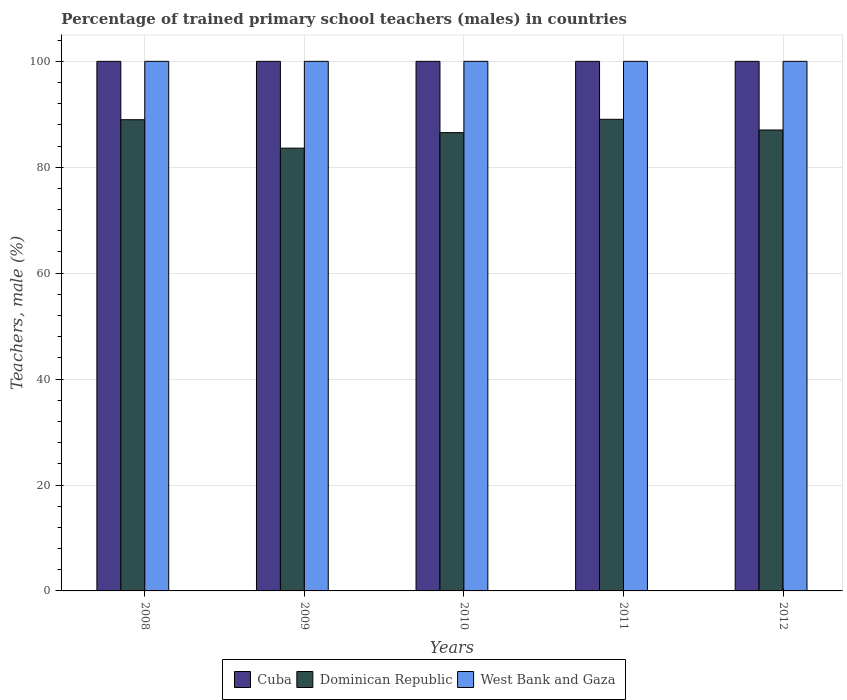Are the number of bars per tick equal to the number of legend labels?
Give a very brief answer. Yes. Are the number of bars on each tick of the X-axis equal?
Offer a terse response. Yes. In how many cases, is the number of bars for a given year not equal to the number of legend labels?
Make the answer very short. 0. What is the percentage of trained primary school teachers (males) in Dominican Republic in 2011?
Make the answer very short. 89.06. Across all years, what is the maximum percentage of trained primary school teachers (males) in Dominican Republic?
Your response must be concise. 89.06. Across all years, what is the minimum percentage of trained primary school teachers (males) in Dominican Republic?
Make the answer very short. 83.61. In which year was the percentage of trained primary school teachers (males) in Dominican Republic maximum?
Offer a terse response. 2011. In which year was the percentage of trained primary school teachers (males) in Dominican Republic minimum?
Offer a very short reply. 2009. What is the total percentage of trained primary school teachers (males) in Dominican Republic in the graph?
Make the answer very short. 435.22. What is the difference between the percentage of trained primary school teachers (males) in Cuba in 2009 and that in 2012?
Provide a short and direct response. 0. What is the difference between the percentage of trained primary school teachers (males) in Cuba in 2011 and the percentage of trained primary school teachers (males) in West Bank and Gaza in 2012?
Provide a succinct answer. 0. In how many years, is the percentage of trained primary school teachers (males) in Dominican Republic greater than 72 %?
Your answer should be compact. 5. What is the difference between the highest and the lowest percentage of trained primary school teachers (males) in West Bank and Gaza?
Make the answer very short. 0. Is the sum of the percentage of trained primary school teachers (males) in Dominican Republic in 2011 and 2012 greater than the maximum percentage of trained primary school teachers (males) in Cuba across all years?
Offer a terse response. Yes. What does the 1st bar from the left in 2010 represents?
Offer a terse response. Cuba. What does the 1st bar from the right in 2010 represents?
Give a very brief answer. West Bank and Gaza. What is the difference between two consecutive major ticks on the Y-axis?
Your response must be concise. 20. Are the values on the major ticks of Y-axis written in scientific E-notation?
Give a very brief answer. No. Does the graph contain grids?
Offer a very short reply. Yes. How many legend labels are there?
Keep it short and to the point. 3. What is the title of the graph?
Provide a succinct answer. Percentage of trained primary school teachers (males) in countries. Does "European Union" appear as one of the legend labels in the graph?
Your answer should be very brief. No. What is the label or title of the X-axis?
Your answer should be very brief. Years. What is the label or title of the Y-axis?
Ensure brevity in your answer.  Teachers, male (%). What is the Teachers, male (%) of Dominican Republic in 2008?
Ensure brevity in your answer.  88.98. What is the Teachers, male (%) of West Bank and Gaza in 2008?
Give a very brief answer. 100. What is the Teachers, male (%) in Cuba in 2009?
Offer a terse response. 100. What is the Teachers, male (%) in Dominican Republic in 2009?
Your answer should be compact. 83.61. What is the Teachers, male (%) of West Bank and Gaza in 2009?
Keep it short and to the point. 100. What is the Teachers, male (%) in Cuba in 2010?
Make the answer very short. 100. What is the Teachers, male (%) of Dominican Republic in 2010?
Keep it short and to the point. 86.54. What is the Teachers, male (%) in Cuba in 2011?
Your answer should be very brief. 100. What is the Teachers, male (%) in Dominican Republic in 2011?
Give a very brief answer. 89.06. What is the Teachers, male (%) of West Bank and Gaza in 2011?
Offer a terse response. 100. What is the Teachers, male (%) of Cuba in 2012?
Keep it short and to the point. 100. What is the Teachers, male (%) of Dominican Republic in 2012?
Provide a short and direct response. 87.04. Across all years, what is the maximum Teachers, male (%) of Dominican Republic?
Offer a very short reply. 89.06. Across all years, what is the minimum Teachers, male (%) of Cuba?
Make the answer very short. 100. Across all years, what is the minimum Teachers, male (%) in Dominican Republic?
Give a very brief answer. 83.61. Across all years, what is the minimum Teachers, male (%) in West Bank and Gaza?
Provide a short and direct response. 100. What is the total Teachers, male (%) in Cuba in the graph?
Provide a short and direct response. 500. What is the total Teachers, male (%) in Dominican Republic in the graph?
Your response must be concise. 435.22. What is the total Teachers, male (%) of West Bank and Gaza in the graph?
Offer a very short reply. 500. What is the difference between the Teachers, male (%) of Cuba in 2008 and that in 2009?
Your response must be concise. 0. What is the difference between the Teachers, male (%) of Dominican Republic in 2008 and that in 2009?
Give a very brief answer. 5.37. What is the difference between the Teachers, male (%) of West Bank and Gaza in 2008 and that in 2009?
Ensure brevity in your answer.  0. What is the difference between the Teachers, male (%) in Cuba in 2008 and that in 2010?
Keep it short and to the point. 0. What is the difference between the Teachers, male (%) of Dominican Republic in 2008 and that in 2010?
Offer a very short reply. 2.44. What is the difference between the Teachers, male (%) of Cuba in 2008 and that in 2011?
Your answer should be very brief. 0. What is the difference between the Teachers, male (%) in Dominican Republic in 2008 and that in 2011?
Your answer should be compact. -0.08. What is the difference between the Teachers, male (%) of West Bank and Gaza in 2008 and that in 2011?
Give a very brief answer. 0. What is the difference between the Teachers, male (%) of Cuba in 2008 and that in 2012?
Keep it short and to the point. 0. What is the difference between the Teachers, male (%) in Dominican Republic in 2008 and that in 2012?
Your answer should be compact. 1.94. What is the difference between the Teachers, male (%) in West Bank and Gaza in 2008 and that in 2012?
Ensure brevity in your answer.  0. What is the difference between the Teachers, male (%) in Cuba in 2009 and that in 2010?
Offer a very short reply. 0. What is the difference between the Teachers, male (%) of Dominican Republic in 2009 and that in 2010?
Provide a succinct answer. -2.93. What is the difference between the Teachers, male (%) of West Bank and Gaza in 2009 and that in 2010?
Provide a succinct answer. 0. What is the difference between the Teachers, male (%) of Dominican Republic in 2009 and that in 2011?
Your answer should be compact. -5.45. What is the difference between the Teachers, male (%) of Cuba in 2009 and that in 2012?
Your answer should be very brief. 0. What is the difference between the Teachers, male (%) in Dominican Republic in 2009 and that in 2012?
Make the answer very short. -3.43. What is the difference between the Teachers, male (%) in Cuba in 2010 and that in 2011?
Your answer should be very brief. 0. What is the difference between the Teachers, male (%) of Dominican Republic in 2010 and that in 2011?
Your response must be concise. -2.52. What is the difference between the Teachers, male (%) in West Bank and Gaza in 2010 and that in 2011?
Keep it short and to the point. 0. What is the difference between the Teachers, male (%) in Dominican Republic in 2010 and that in 2012?
Offer a terse response. -0.5. What is the difference between the Teachers, male (%) in Dominican Republic in 2011 and that in 2012?
Make the answer very short. 2.02. What is the difference between the Teachers, male (%) in Cuba in 2008 and the Teachers, male (%) in Dominican Republic in 2009?
Keep it short and to the point. 16.39. What is the difference between the Teachers, male (%) in Cuba in 2008 and the Teachers, male (%) in West Bank and Gaza in 2009?
Provide a succinct answer. 0. What is the difference between the Teachers, male (%) of Dominican Republic in 2008 and the Teachers, male (%) of West Bank and Gaza in 2009?
Give a very brief answer. -11.02. What is the difference between the Teachers, male (%) in Cuba in 2008 and the Teachers, male (%) in Dominican Republic in 2010?
Provide a short and direct response. 13.46. What is the difference between the Teachers, male (%) in Dominican Republic in 2008 and the Teachers, male (%) in West Bank and Gaza in 2010?
Offer a terse response. -11.02. What is the difference between the Teachers, male (%) in Cuba in 2008 and the Teachers, male (%) in Dominican Republic in 2011?
Offer a very short reply. 10.94. What is the difference between the Teachers, male (%) of Dominican Republic in 2008 and the Teachers, male (%) of West Bank and Gaza in 2011?
Your answer should be compact. -11.02. What is the difference between the Teachers, male (%) of Cuba in 2008 and the Teachers, male (%) of Dominican Republic in 2012?
Ensure brevity in your answer.  12.96. What is the difference between the Teachers, male (%) in Dominican Republic in 2008 and the Teachers, male (%) in West Bank and Gaza in 2012?
Ensure brevity in your answer.  -11.02. What is the difference between the Teachers, male (%) in Cuba in 2009 and the Teachers, male (%) in Dominican Republic in 2010?
Provide a short and direct response. 13.46. What is the difference between the Teachers, male (%) in Cuba in 2009 and the Teachers, male (%) in West Bank and Gaza in 2010?
Provide a succinct answer. 0. What is the difference between the Teachers, male (%) of Dominican Republic in 2009 and the Teachers, male (%) of West Bank and Gaza in 2010?
Provide a succinct answer. -16.39. What is the difference between the Teachers, male (%) of Cuba in 2009 and the Teachers, male (%) of Dominican Republic in 2011?
Make the answer very short. 10.94. What is the difference between the Teachers, male (%) of Cuba in 2009 and the Teachers, male (%) of West Bank and Gaza in 2011?
Your response must be concise. 0. What is the difference between the Teachers, male (%) in Dominican Republic in 2009 and the Teachers, male (%) in West Bank and Gaza in 2011?
Keep it short and to the point. -16.39. What is the difference between the Teachers, male (%) in Cuba in 2009 and the Teachers, male (%) in Dominican Republic in 2012?
Provide a short and direct response. 12.96. What is the difference between the Teachers, male (%) of Cuba in 2009 and the Teachers, male (%) of West Bank and Gaza in 2012?
Ensure brevity in your answer.  0. What is the difference between the Teachers, male (%) of Dominican Republic in 2009 and the Teachers, male (%) of West Bank and Gaza in 2012?
Provide a short and direct response. -16.39. What is the difference between the Teachers, male (%) in Cuba in 2010 and the Teachers, male (%) in Dominican Republic in 2011?
Offer a very short reply. 10.94. What is the difference between the Teachers, male (%) of Dominican Republic in 2010 and the Teachers, male (%) of West Bank and Gaza in 2011?
Ensure brevity in your answer.  -13.46. What is the difference between the Teachers, male (%) of Cuba in 2010 and the Teachers, male (%) of Dominican Republic in 2012?
Provide a succinct answer. 12.96. What is the difference between the Teachers, male (%) in Cuba in 2010 and the Teachers, male (%) in West Bank and Gaza in 2012?
Your response must be concise. 0. What is the difference between the Teachers, male (%) in Dominican Republic in 2010 and the Teachers, male (%) in West Bank and Gaza in 2012?
Provide a succinct answer. -13.46. What is the difference between the Teachers, male (%) in Cuba in 2011 and the Teachers, male (%) in Dominican Republic in 2012?
Provide a succinct answer. 12.96. What is the difference between the Teachers, male (%) of Cuba in 2011 and the Teachers, male (%) of West Bank and Gaza in 2012?
Offer a very short reply. 0. What is the difference between the Teachers, male (%) in Dominican Republic in 2011 and the Teachers, male (%) in West Bank and Gaza in 2012?
Make the answer very short. -10.94. What is the average Teachers, male (%) of Dominican Republic per year?
Provide a succinct answer. 87.04. What is the average Teachers, male (%) in West Bank and Gaza per year?
Keep it short and to the point. 100. In the year 2008, what is the difference between the Teachers, male (%) in Cuba and Teachers, male (%) in Dominican Republic?
Your answer should be very brief. 11.02. In the year 2008, what is the difference between the Teachers, male (%) in Dominican Republic and Teachers, male (%) in West Bank and Gaza?
Your answer should be very brief. -11.02. In the year 2009, what is the difference between the Teachers, male (%) of Cuba and Teachers, male (%) of Dominican Republic?
Provide a succinct answer. 16.39. In the year 2009, what is the difference between the Teachers, male (%) of Dominican Republic and Teachers, male (%) of West Bank and Gaza?
Your answer should be compact. -16.39. In the year 2010, what is the difference between the Teachers, male (%) in Cuba and Teachers, male (%) in Dominican Republic?
Your answer should be compact. 13.46. In the year 2010, what is the difference between the Teachers, male (%) in Cuba and Teachers, male (%) in West Bank and Gaza?
Provide a succinct answer. 0. In the year 2010, what is the difference between the Teachers, male (%) of Dominican Republic and Teachers, male (%) of West Bank and Gaza?
Keep it short and to the point. -13.46. In the year 2011, what is the difference between the Teachers, male (%) in Cuba and Teachers, male (%) in Dominican Republic?
Offer a terse response. 10.94. In the year 2011, what is the difference between the Teachers, male (%) of Dominican Republic and Teachers, male (%) of West Bank and Gaza?
Offer a terse response. -10.94. In the year 2012, what is the difference between the Teachers, male (%) in Cuba and Teachers, male (%) in Dominican Republic?
Keep it short and to the point. 12.96. In the year 2012, what is the difference between the Teachers, male (%) in Cuba and Teachers, male (%) in West Bank and Gaza?
Your answer should be very brief. 0. In the year 2012, what is the difference between the Teachers, male (%) in Dominican Republic and Teachers, male (%) in West Bank and Gaza?
Offer a very short reply. -12.96. What is the ratio of the Teachers, male (%) in Dominican Republic in 2008 to that in 2009?
Your response must be concise. 1.06. What is the ratio of the Teachers, male (%) of Cuba in 2008 to that in 2010?
Offer a very short reply. 1. What is the ratio of the Teachers, male (%) of Dominican Republic in 2008 to that in 2010?
Offer a terse response. 1.03. What is the ratio of the Teachers, male (%) of Cuba in 2008 to that in 2011?
Provide a short and direct response. 1. What is the ratio of the Teachers, male (%) in Dominican Republic in 2008 to that in 2011?
Offer a terse response. 1. What is the ratio of the Teachers, male (%) of West Bank and Gaza in 2008 to that in 2011?
Your answer should be very brief. 1. What is the ratio of the Teachers, male (%) in Cuba in 2008 to that in 2012?
Make the answer very short. 1. What is the ratio of the Teachers, male (%) in Dominican Republic in 2008 to that in 2012?
Offer a terse response. 1.02. What is the ratio of the Teachers, male (%) of Dominican Republic in 2009 to that in 2010?
Provide a succinct answer. 0.97. What is the ratio of the Teachers, male (%) of Cuba in 2009 to that in 2011?
Provide a succinct answer. 1. What is the ratio of the Teachers, male (%) of Dominican Republic in 2009 to that in 2011?
Your answer should be compact. 0.94. What is the ratio of the Teachers, male (%) in West Bank and Gaza in 2009 to that in 2011?
Your answer should be compact. 1. What is the ratio of the Teachers, male (%) in Cuba in 2009 to that in 2012?
Ensure brevity in your answer.  1. What is the ratio of the Teachers, male (%) in Dominican Republic in 2009 to that in 2012?
Offer a terse response. 0.96. What is the ratio of the Teachers, male (%) in West Bank and Gaza in 2009 to that in 2012?
Your answer should be compact. 1. What is the ratio of the Teachers, male (%) in Cuba in 2010 to that in 2011?
Make the answer very short. 1. What is the ratio of the Teachers, male (%) of Dominican Republic in 2010 to that in 2011?
Provide a short and direct response. 0.97. What is the ratio of the Teachers, male (%) in Dominican Republic in 2010 to that in 2012?
Ensure brevity in your answer.  0.99. What is the ratio of the Teachers, male (%) in West Bank and Gaza in 2010 to that in 2012?
Make the answer very short. 1. What is the ratio of the Teachers, male (%) in Dominican Republic in 2011 to that in 2012?
Offer a terse response. 1.02. What is the ratio of the Teachers, male (%) of West Bank and Gaza in 2011 to that in 2012?
Offer a terse response. 1. What is the difference between the highest and the second highest Teachers, male (%) of Cuba?
Make the answer very short. 0. What is the difference between the highest and the second highest Teachers, male (%) of Dominican Republic?
Offer a very short reply. 0.08. What is the difference between the highest and the second highest Teachers, male (%) of West Bank and Gaza?
Offer a very short reply. 0. What is the difference between the highest and the lowest Teachers, male (%) of Dominican Republic?
Keep it short and to the point. 5.45. What is the difference between the highest and the lowest Teachers, male (%) of West Bank and Gaza?
Keep it short and to the point. 0. 